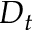<formula> <loc_0><loc_0><loc_500><loc_500>D _ { t }</formula> 